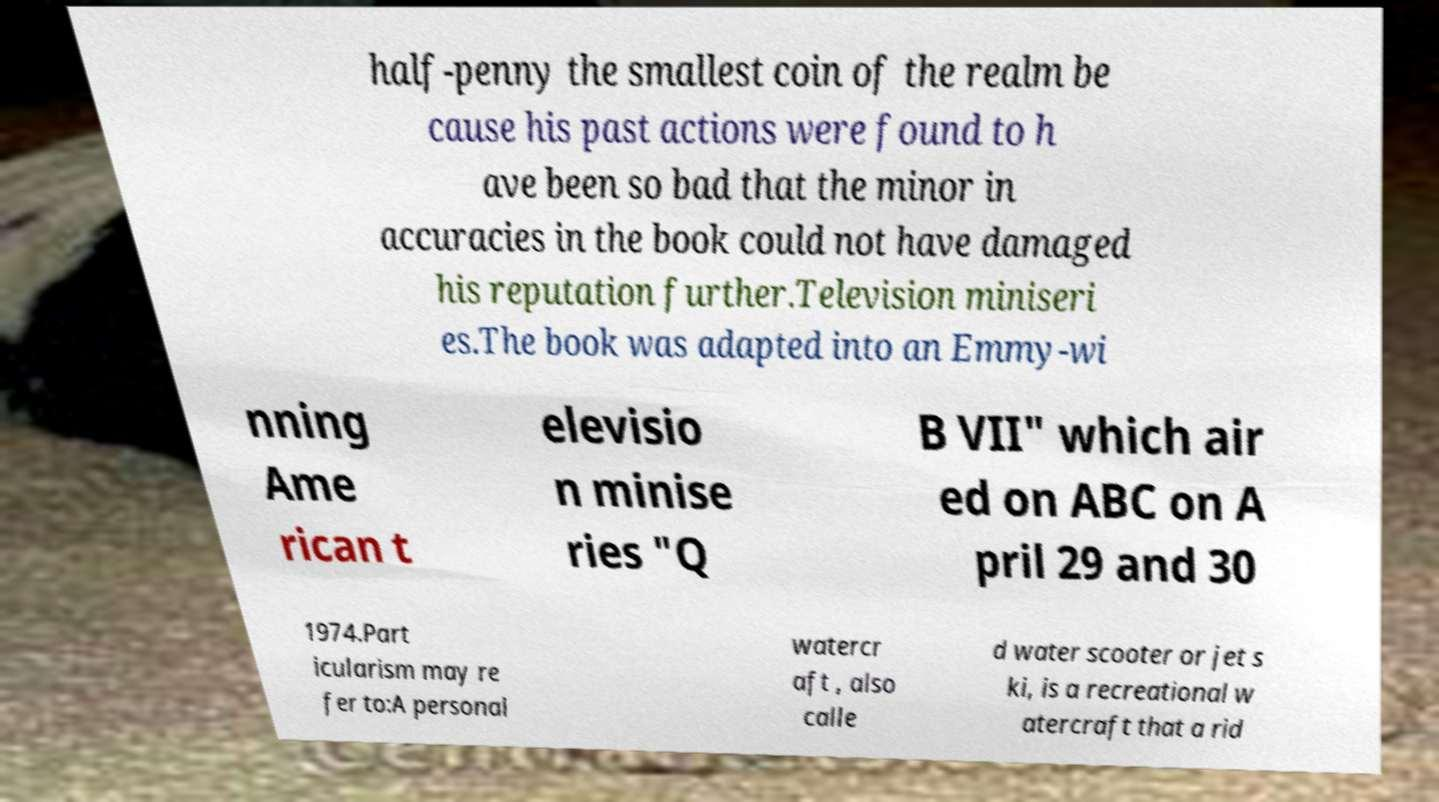Can you read and provide the text displayed in the image?This photo seems to have some interesting text. Can you extract and type it out for me? half-penny the smallest coin of the realm be cause his past actions were found to h ave been so bad that the minor in accuracies in the book could not have damaged his reputation further.Television miniseri es.The book was adapted into an Emmy-wi nning Ame rican t elevisio n minise ries "Q B VII" which air ed on ABC on A pril 29 and 30 1974.Part icularism may re fer to:A personal watercr aft , also calle d water scooter or jet s ki, is a recreational w atercraft that a rid 